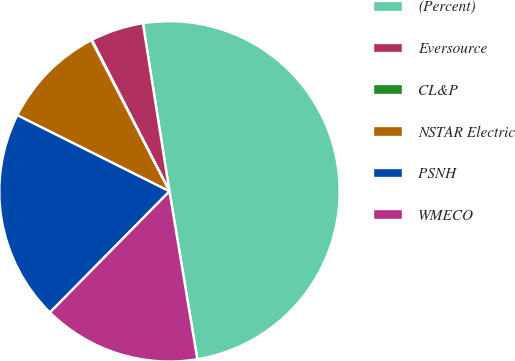<chart> <loc_0><loc_0><loc_500><loc_500><pie_chart><fcel>(Percent)<fcel>Eversource<fcel>CL&P<fcel>NSTAR Electric<fcel>PSNH<fcel>WMECO<nl><fcel>49.88%<fcel>5.04%<fcel>0.06%<fcel>10.02%<fcel>19.99%<fcel>15.01%<nl></chart> 